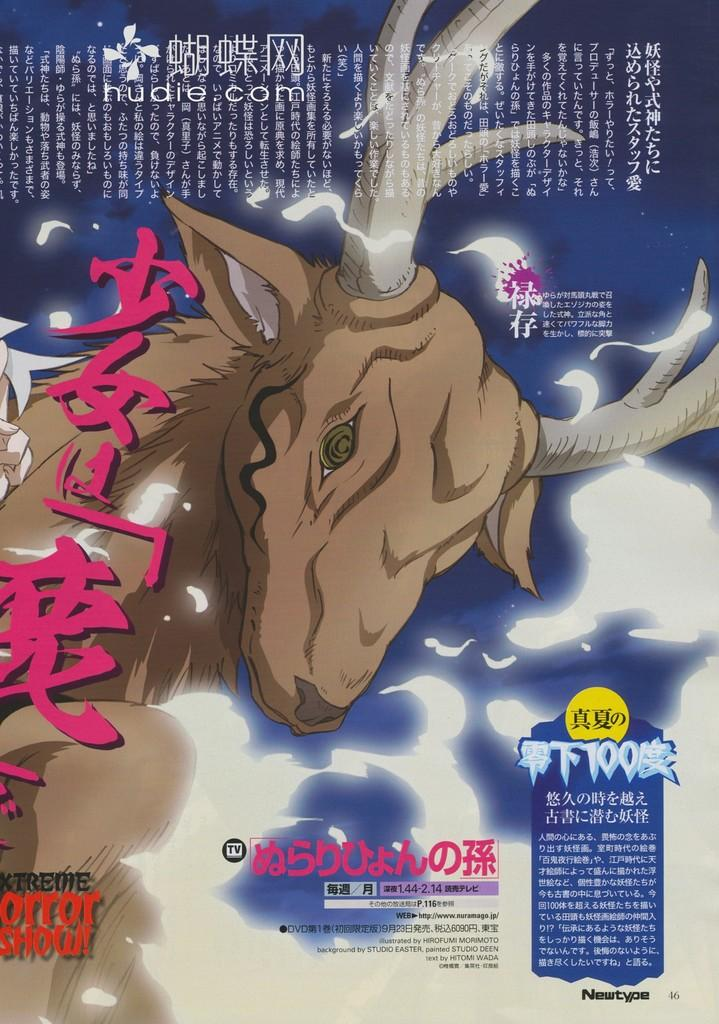What type of character is depicted in the image? There is an animated animal in the image. Can you describe the color scheme of the animal? The animal is in brown and cream colors. What else is present in the image besides the animal? There is text written on the image. What colors are used for the background of the image? The background of the image is in blue and white colors. How many ducks are sitting under the umbrella in the image? There are no ducks or umbrellas present in the image. What type of wool is used to create the animal's fur in the image? The image is animated, and therefore, it does not depict real wool or fur. 